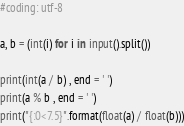Convert code to text. <code><loc_0><loc_0><loc_500><loc_500><_Python_>#coding: utf-8

a, b = (int(i) for i in input().split())

print(int(a / b) , end = ' ')
print(a % b , end = ' ')
print("{:0<7.5}".format(float(a) / float(b)))
</code> 